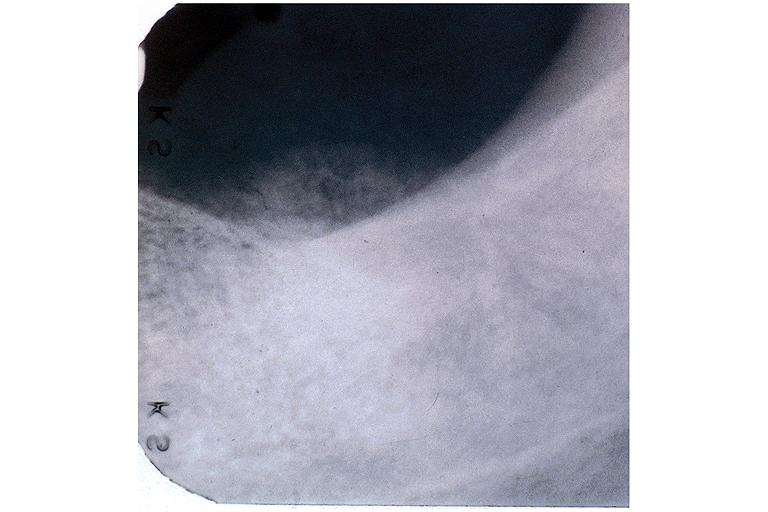s oral present?
Answer the question using a single word or phrase. Yes 